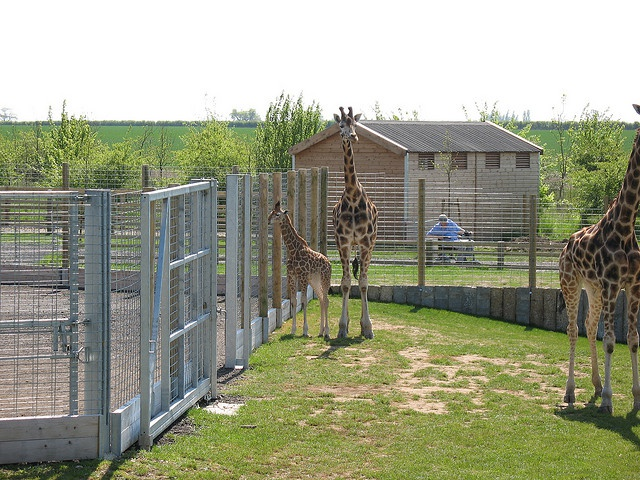Describe the objects in this image and their specific colors. I can see giraffe in white, black, and gray tones, giraffe in white, gray, black, and olive tones, giraffe in white, gray, black, and olive tones, and people in white, gray, darkgray, and black tones in this image. 